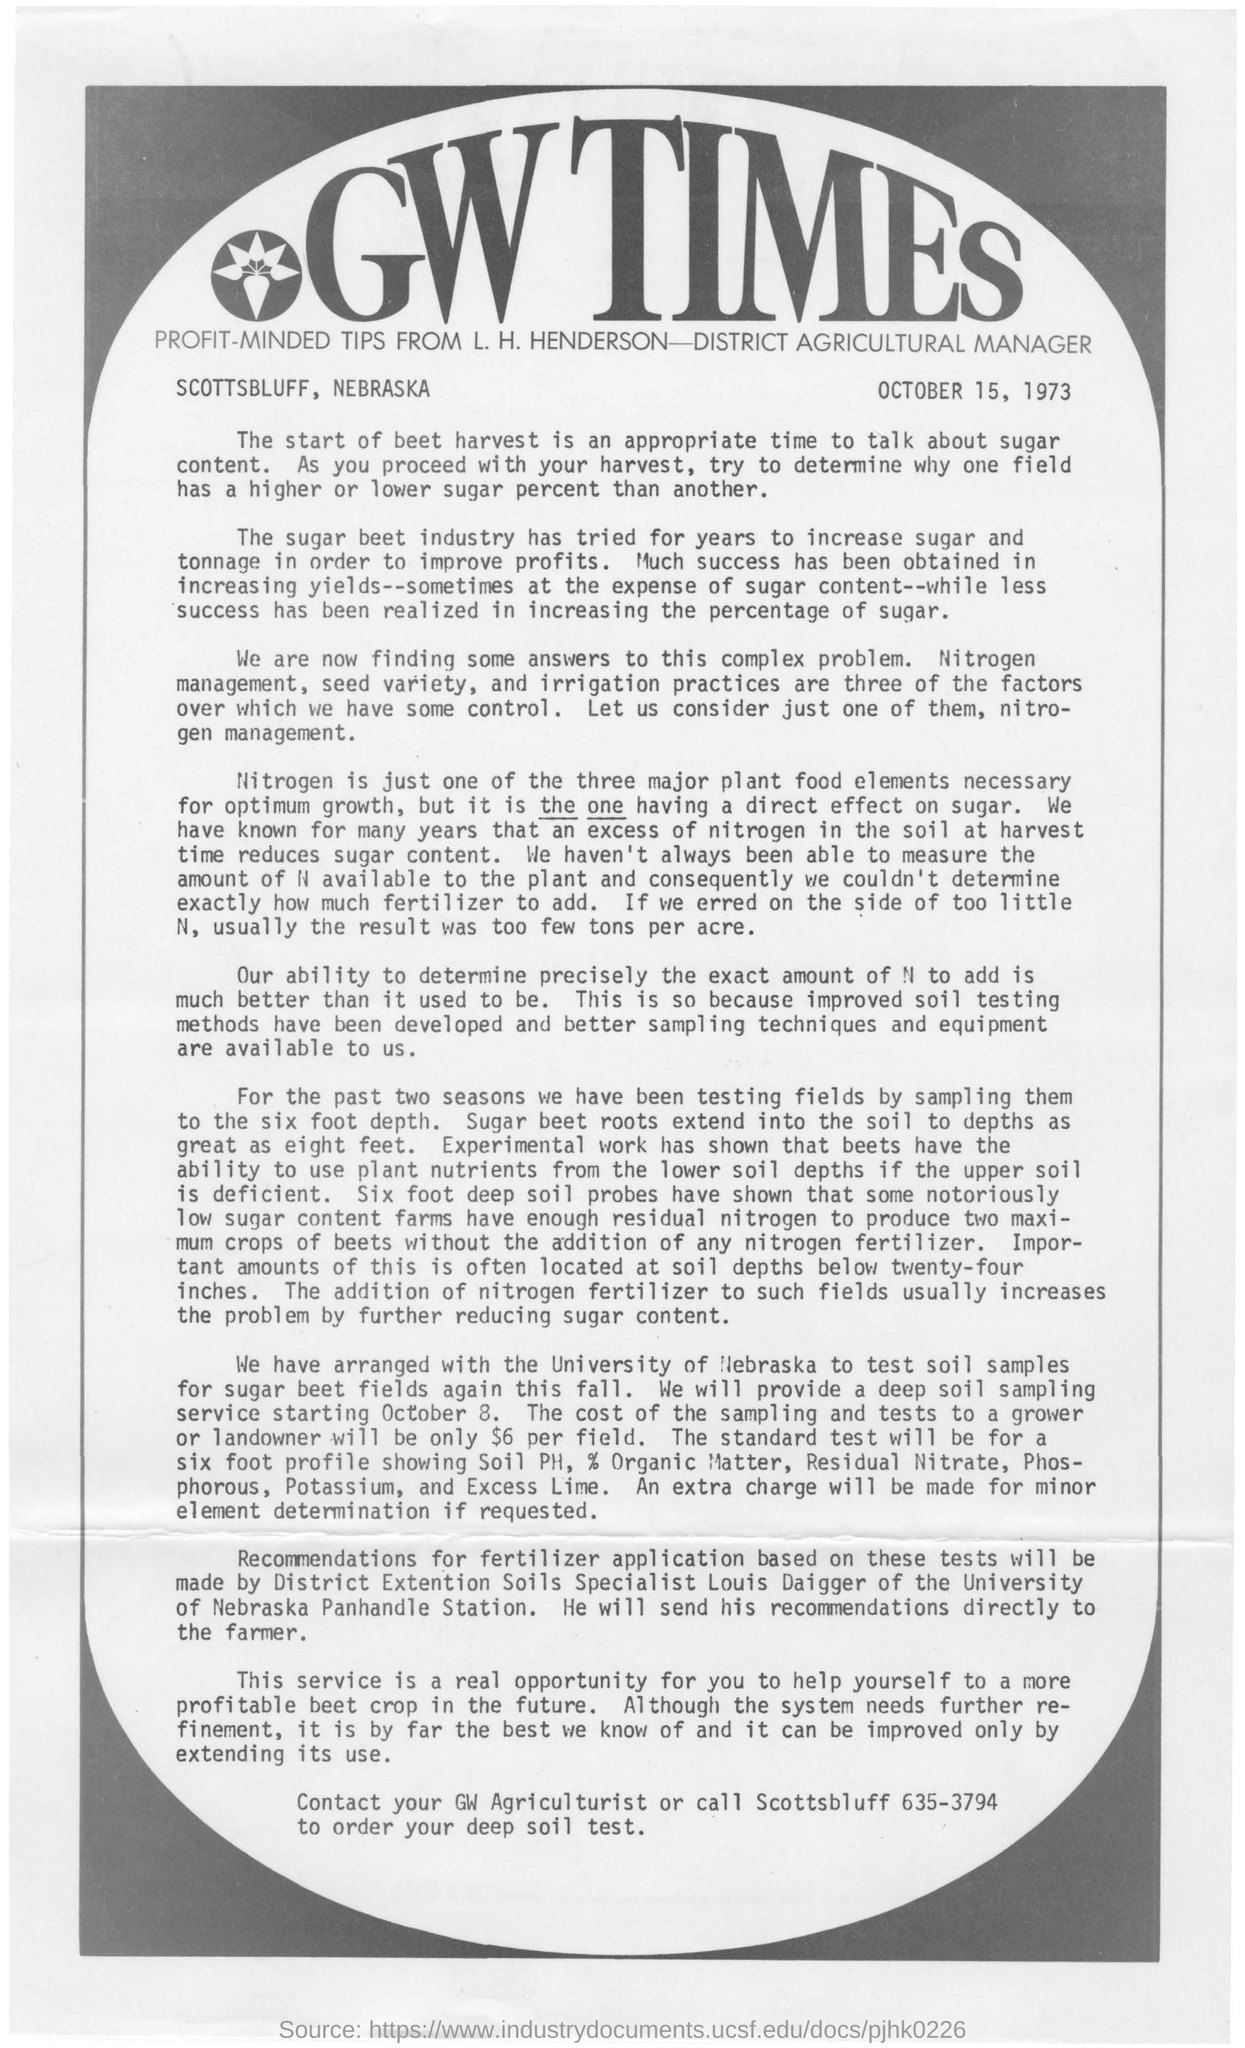What is written at the top in big fancy letters?
Offer a terse response. GW TIMES. What date is mentioned in this page at the top right?
Your answer should be very brief. October 15, 1973. What is the major plant food elements necessary for optimum growth?
Your response must be concise. Nitrogen. What is the effect of excess of nitrogen in the soil at harvest time?
Ensure brevity in your answer.  Reduces sugar content. What is the cost of sampling and tests to grower or landowner?
Your answer should be compact. $6 per field. 